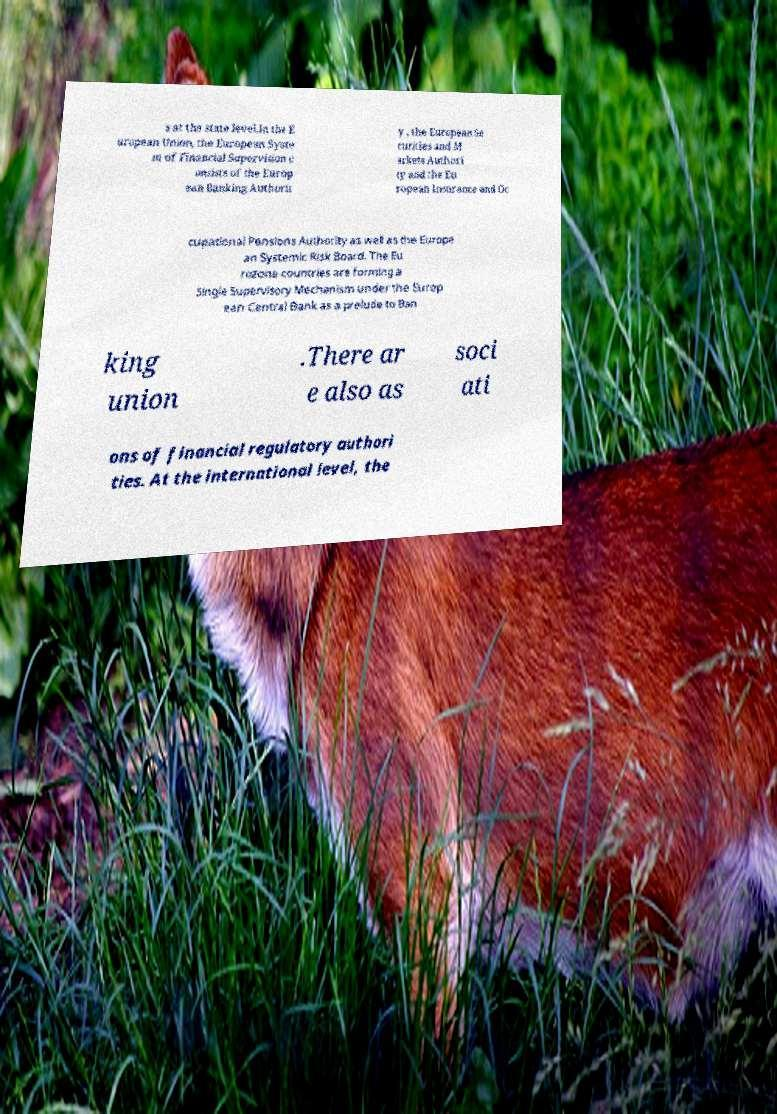For documentation purposes, I need the text within this image transcribed. Could you provide that? s at the state level.In the E uropean Union, the European Syste m of Financial Supervision c onsists of the Europ ean Banking Authorit y , the European Se curities and M arkets Authori ty and the Eu ropean Insurance and Oc cupational Pensions Authority as well as the Europe an Systemic Risk Board. The Eu rozone countries are forming a Single Supervisory Mechanism under the Europ ean Central Bank as a prelude to Ban king union .There ar e also as soci ati ons of financial regulatory authori ties. At the international level, the 